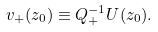<formula> <loc_0><loc_0><loc_500><loc_500>v _ { + } ( z _ { 0 } ) \equiv Q _ { + } ^ { - 1 } U ( z _ { 0 } ) .</formula> 